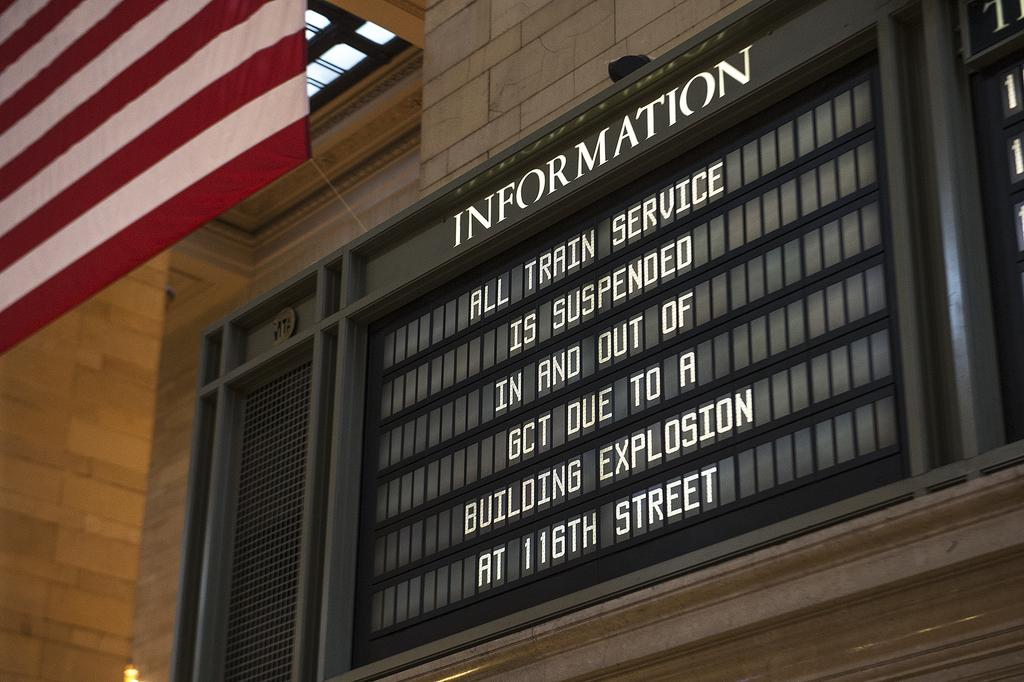What is on the building in the image? There is an information board on the building. What can be found on the information board? There is text on the information board. What else is visible in the image besides the information board? There is a flag visible in the image. Can you see anyone smiling at the seashore in the image? There is no seashore or people visible in the image, so it is not possible to see anyone smiling. 